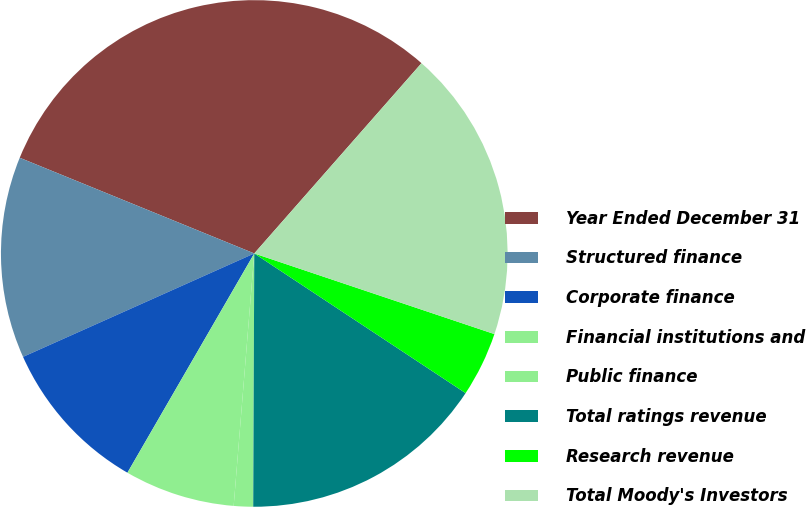Convert chart to OTSL. <chart><loc_0><loc_0><loc_500><loc_500><pie_chart><fcel>Year Ended December 31<fcel>Structured finance<fcel>Corporate finance<fcel>Financial institutions and<fcel>Public finance<fcel>Total ratings revenue<fcel>Research revenue<fcel>Total Moody's Investors<nl><fcel>30.31%<fcel>12.86%<fcel>9.96%<fcel>7.05%<fcel>1.23%<fcel>15.77%<fcel>4.14%<fcel>18.68%<nl></chart> 